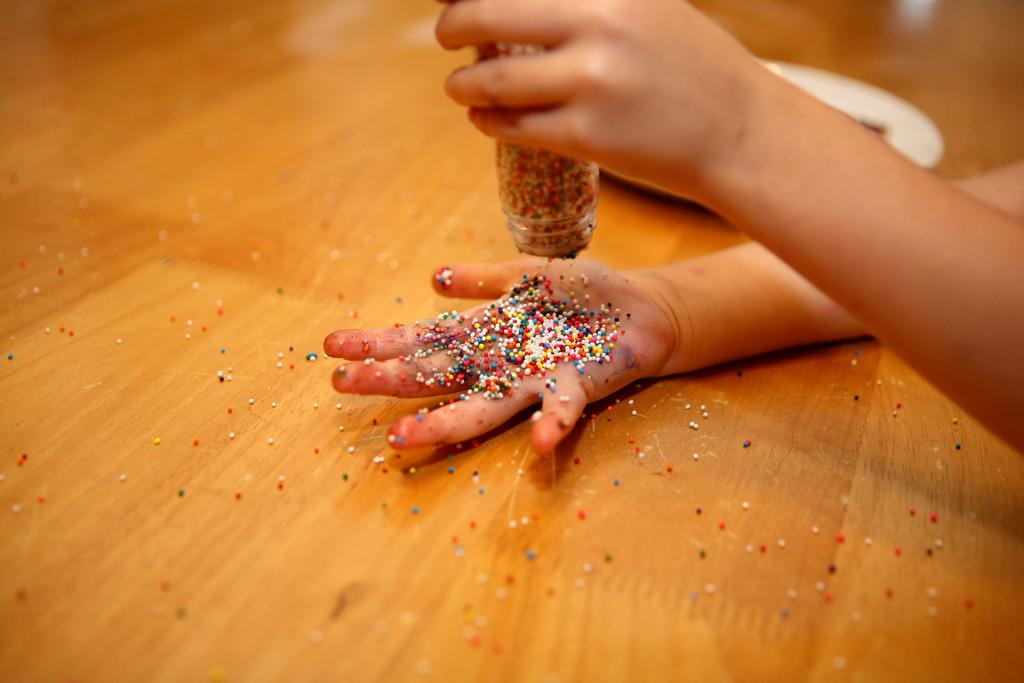What type of furniture is present in the image? There is a table in the image. What is the person in the image doing with their hand? A person's hand is holding a bottle in the image. What can be seen on the table besides the hand holding the bottle? There is a white color plate on the table. What size of sock is the person wearing in the image? There is no sock visible in the image, and therefore no information about its size can be provided. What type of government is depicted in the image? There is no reference to any government or political entity in the image. 